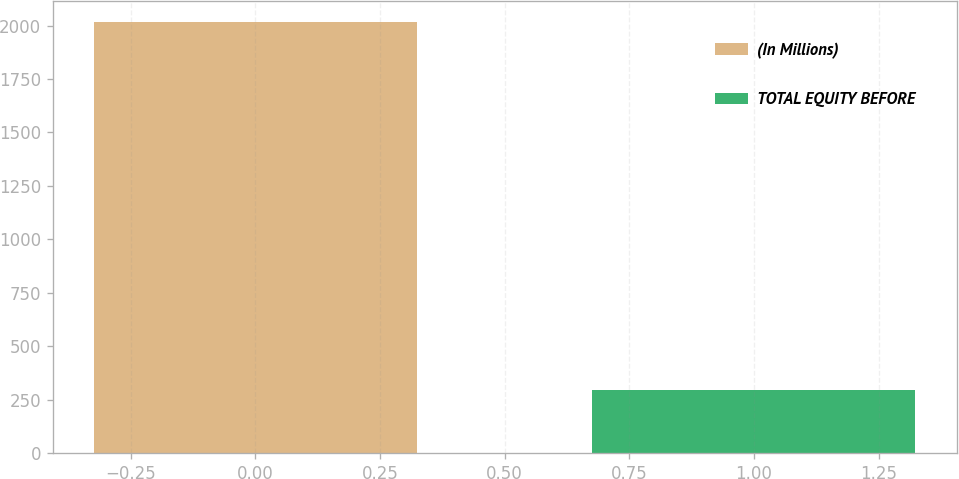<chart> <loc_0><loc_0><loc_500><loc_500><bar_chart><fcel>(In Millions)<fcel>TOTAL EQUITY BEFORE<nl><fcel>2015<fcel>293<nl></chart> 